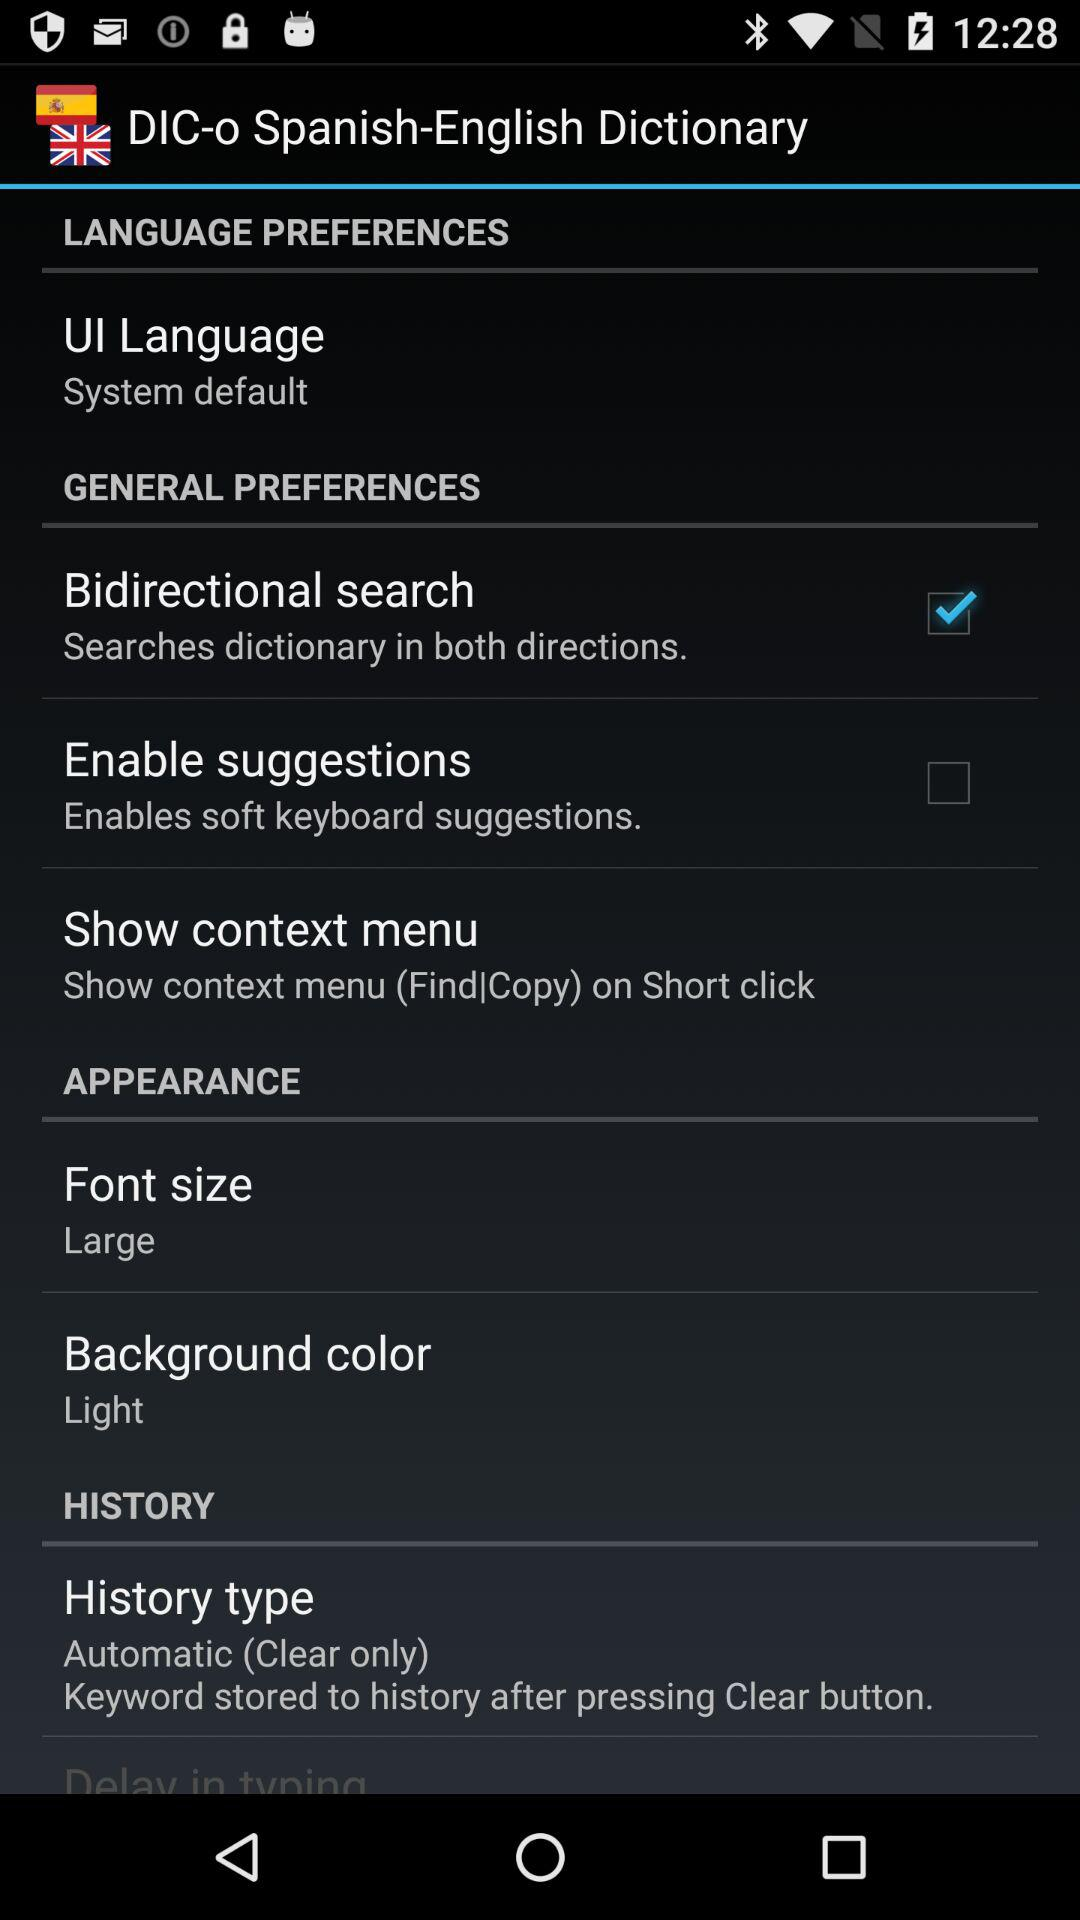What is the background color? The background color is light. 